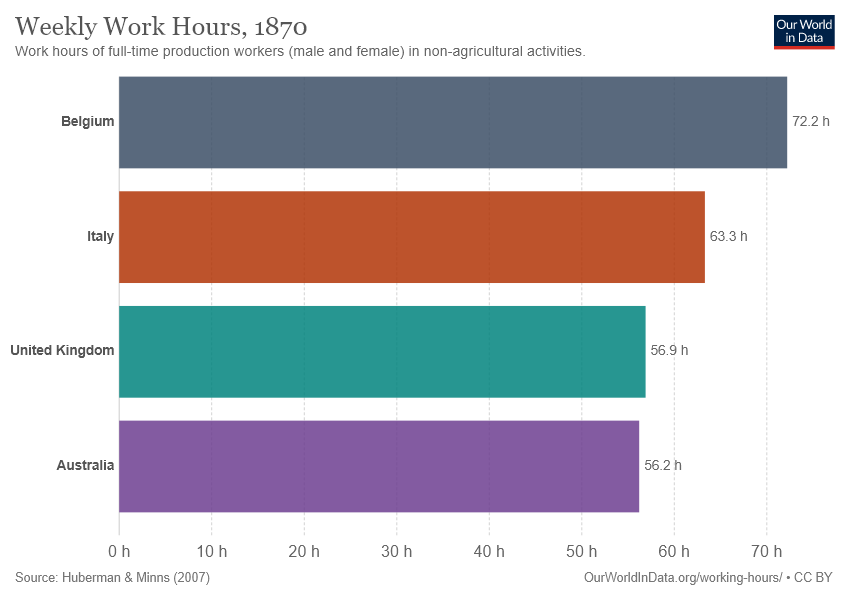Point out several critical features in this image. The purple bar represents Australia. The sum of the United Kingdom and Australia is greater than that of Belgium, as stated. 